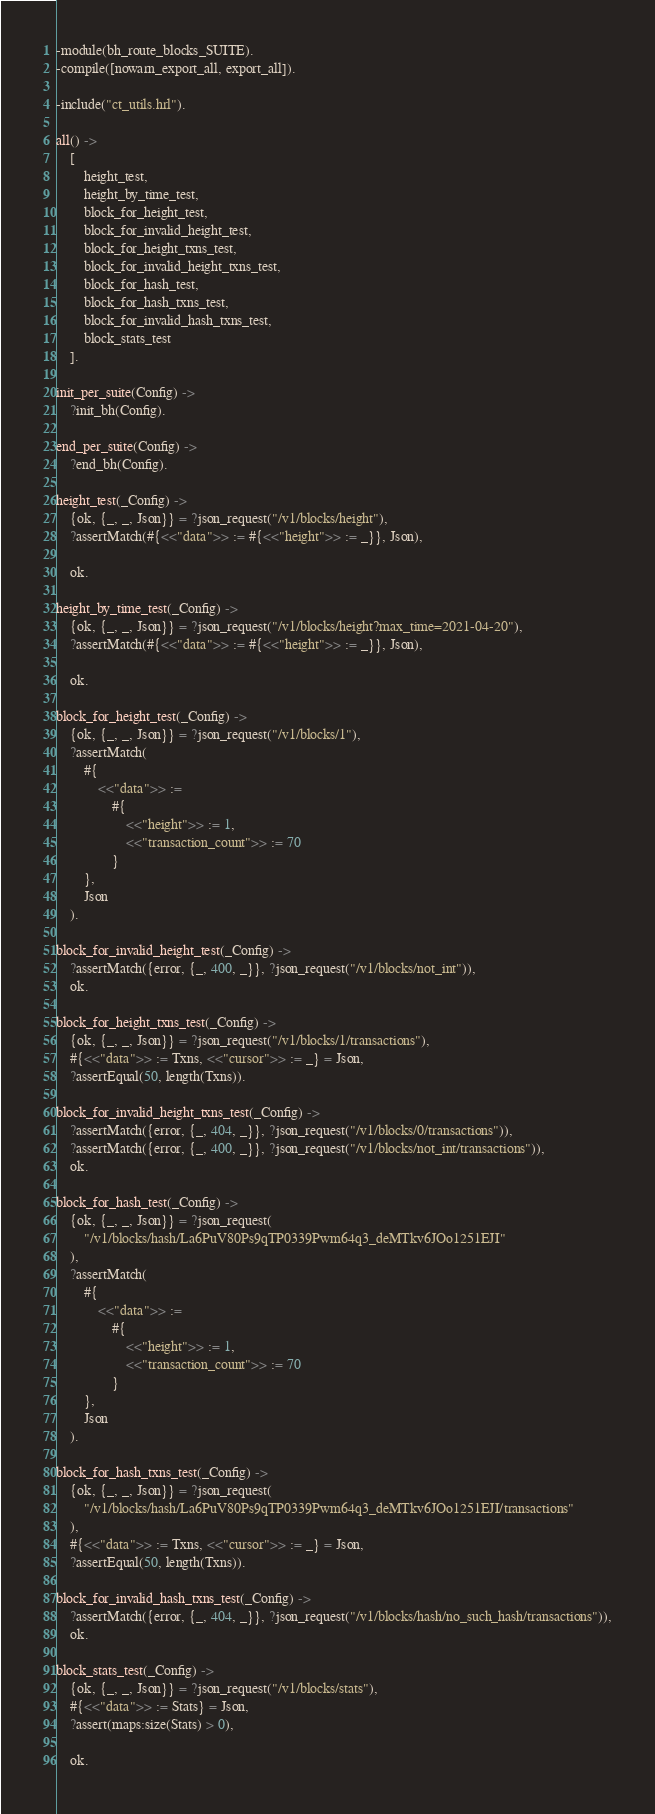<code> <loc_0><loc_0><loc_500><loc_500><_Erlang_>-module(bh_route_blocks_SUITE).
-compile([nowarn_export_all, export_all]).

-include("ct_utils.hrl").

all() ->
    [
        height_test,
        height_by_time_test,
        block_for_height_test,
        block_for_invalid_height_test,
        block_for_height_txns_test,
        block_for_invalid_height_txns_test,
        block_for_hash_test,
        block_for_hash_txns_test,
        block_for_invalid_hash_txns_test,
        block_stats_test
    ].

init_per_suite(Config) ->
    ?init_bh(Config).

end_per_suite(Config) ->
    ?end_bh(Config).

height_test(_Config) ->
    {ok, {_, _, Json}} = ?json_request("/v1/blocks/height"),
    ?assertMatch(#{<<"data">> := #{<<"height">> := _}}, Json),

    ok.

height_by_time_test(_Config) ->
    {ok, {_, _, Json}} = ?json_request("/v1/blocks/height?max_time=2021-04-20"),
    ?assertMatch(#{<<"data">> := #{<<"height">> := _}}, Json),

    ok.

block_for_height_test(_Config) ->
    {ok, {_, _, Json}} = ?json_request("/v1/blocks/1"),
    ?assertMatch(
        #{
            <<"data">> :=
                #{
                    <<"height">> := 1,
                    <<"transaction_count">> := 70
                }
        },
        Json
    ).

block_for_invalid_height_test(_Config) ->
    ?assertMatch({error, {_, 400, _}}, ?json_request("/v1/blocks/not_int")),
    ok.

block_for_height_txns_test(_Config) ->
    {ok, {_, _, Json}} = ?json_request("/v1/blocks/1/transactions"),
    #{<<"data">> := Txns, <<"cursor">> := _} = Json,
    ?assertEqual(50, length(Txns)).

block_for_invalid_height_txns_test(_Config) ->
    ?assertMatch({error, {_, 404, _}}, ?json_request("/v1/blocks/0/transactions")),
    ?assertMatch({error, {_, 400, _}}, ?json_request("/v1/blocks/not_int/transactions")),
    ok.

block_for_hash_test(_Config) ->
    {ok, {_, _, Json}} = ?json_request(
        "/v1/blocks/hash/La6PuV80Ps9qTP0339Pwm64q3_deMTkv6JOo1251EJI"
    ),
    ?assertMatch(
        #{
            <<"data">> :=
                #{
                    <<"height">> := 1,
                    <<"transaction_count">> := 70
                }
        },
        Json
    ).

block_for_hash_txns_test(_Config) ->
    {ok, {_, _, Json}} = ?json_request(
        "/v1/blocks/hash/La6PuV80Ps9qTP0339Pwm64q3_deMTkv6JOo1251EJI/transactions"
    ),
    #{<<"data">> := Txns, <<"cursor">> := _} = Json,
    ?assertEqual(50, length(Txns)).

block_for_invalid_hash_txns_test(_Config) ->
    ?assertMatch({error, {_, 404, _}}, ?json_request("/v1/blocks/hash/no_such_hash/transactions")),
    ok.

block_stats_test(_Config) ->
    {ok, {_, _, Json}} = ?json_request("/v1/blocks/stats"),
    #{<<"data">> := Stats} = Json,
    ?assert(maps:size(Stats) > 0),

    ok.
</code> 